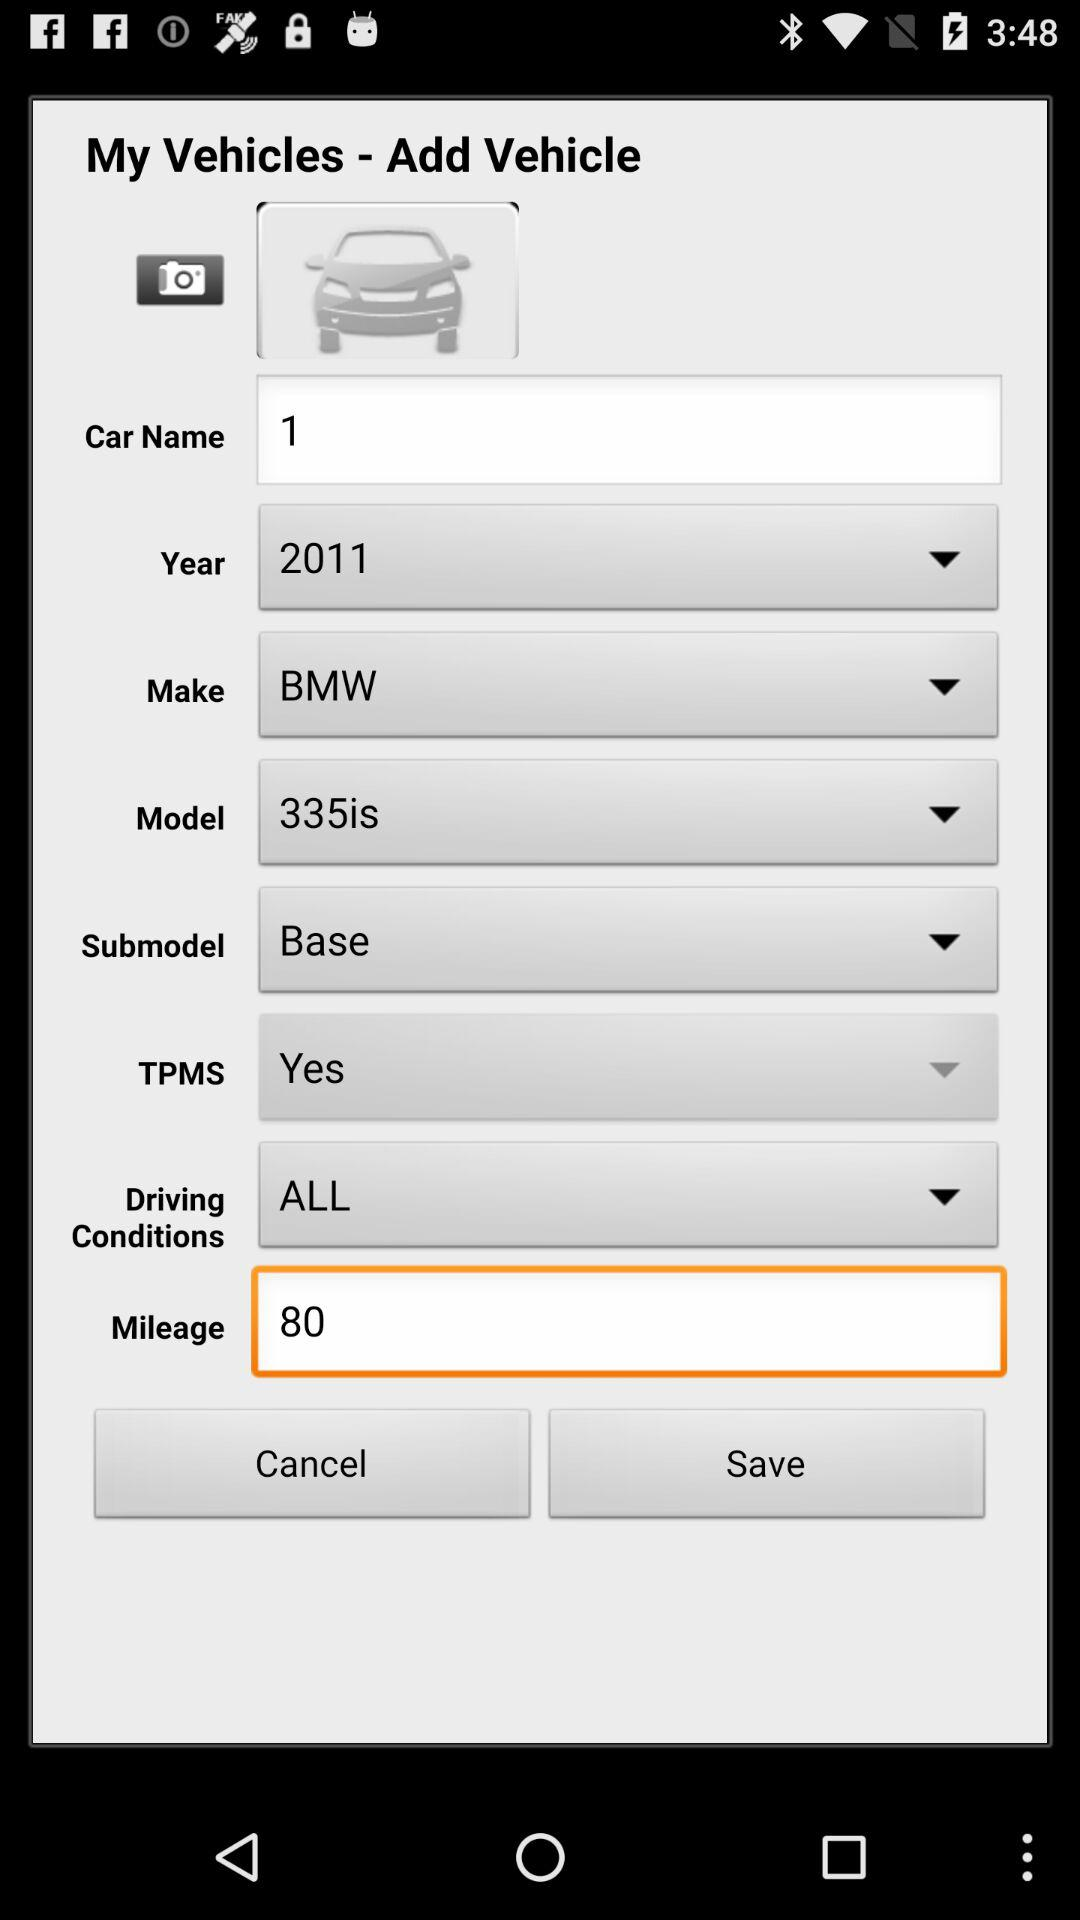What is the model year of the car? The model year of the car is 2011. 